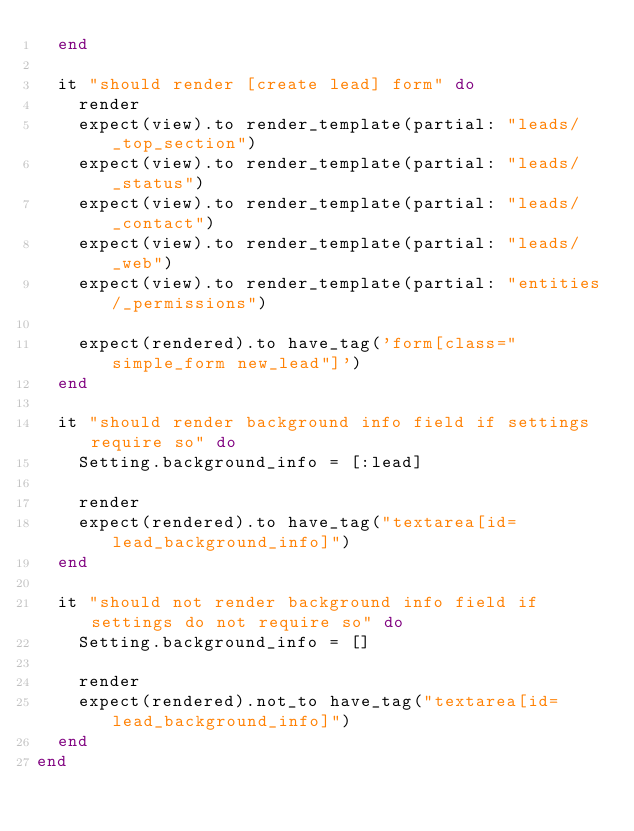<code> <loc_0><loc_0><loc_500><loc_500><_Ruby_>  end

  it "should render [create lead] form" do
    render
    expect(view).to render_template(partial: "leads/_top_section")
    expect(view).to render_template(partial: "leads/_status")
    expect(view).to render_template(partial: "leads/_contact")
    expect(view).to render_template(partial: "leads/_web")
    expect(view).to render_template(partial: "entities/_permissions")

    expect(rendered).to have_tag('form[class="simple_form new_lead"]')
  end

  it "should render background info field if settings require so" do
    Setting.background_info = [:lead]

    render
    expect(rendered).to have_tag("textarea[id=lead_background_info]")
  end

  it "should not render background info field if settings do not require so" do
    Setting.background_info = []

    render
    expect(rendered).not_to have_tag("textarea[id=lead_background_info]")
  end
end
</code> 